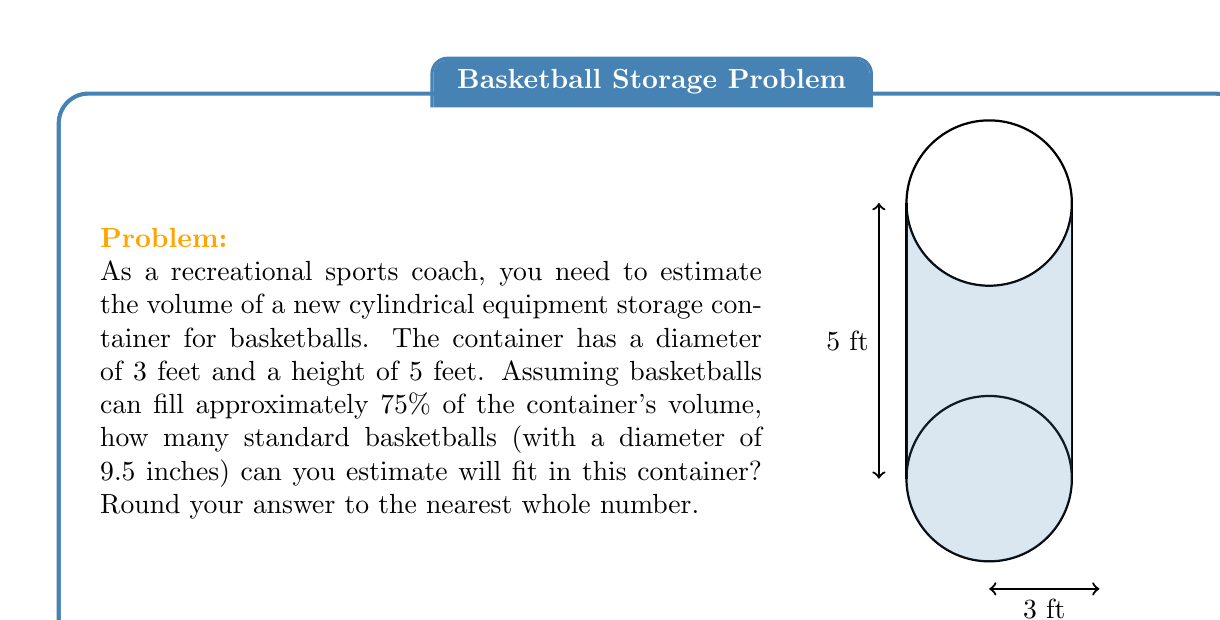What is the answer to this math problem? Let's approach this step-by-step:

1) First, calculate the volume of the cylindrical container:
   $$V_{container} = \pi r^2 h$$
   where $r$ is the radius (1.5 feet) and $h$ is the height (5 feet).
   $$V_{container} = \pi (1.5\text{ ft})^2 (5\text{ ft}) \approx 35.34 \text{ cubic feet}$$

2) The usable volume is 75% of the total volume:
   $$V_{usable} = 0.75 \times 35.34 \text{ ft}^3 \approx 26.51 \text{ ft}^3$$

3) Now, calculate the volume of a basketball:
   Diameter = 9.5 inches = 0.7917 feet
   Radius = 0.7917 / 2 = 0.3958 feet
   $$V_{ball} = \frac{4}{3}\pi r^3 = \frac{4}{3}\pi (0.3958\text{ ft})^3 \approx 0.2595 \text{ ft}^3$$

4) Estimate the number of basketballs:
   $$\text{Number of balls} = \frac{V_{usable}}{V_{ball}} = \frac{26.51 \text{ ft}^3}{0.2595 \text{ ft}^3} \approx 102.16$$

5) Rounding to the nearest whole number: 102 basketballs.
Answer: 102 basketballs 